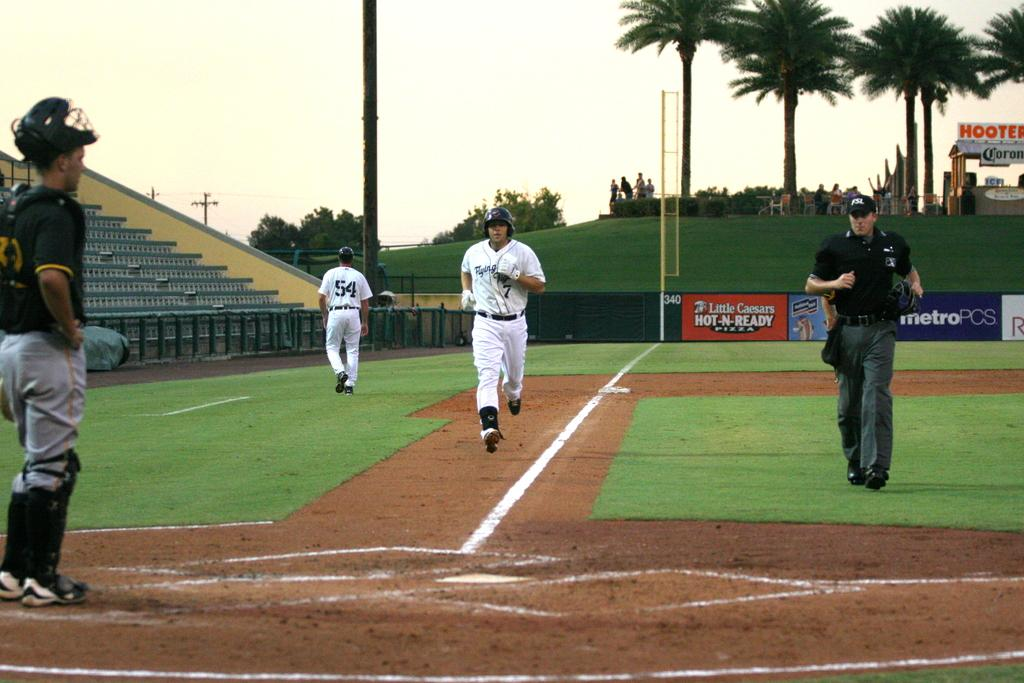<image>
Create a compact narrative representing the image presented. The player in the white jersey running to home plate is number 7 